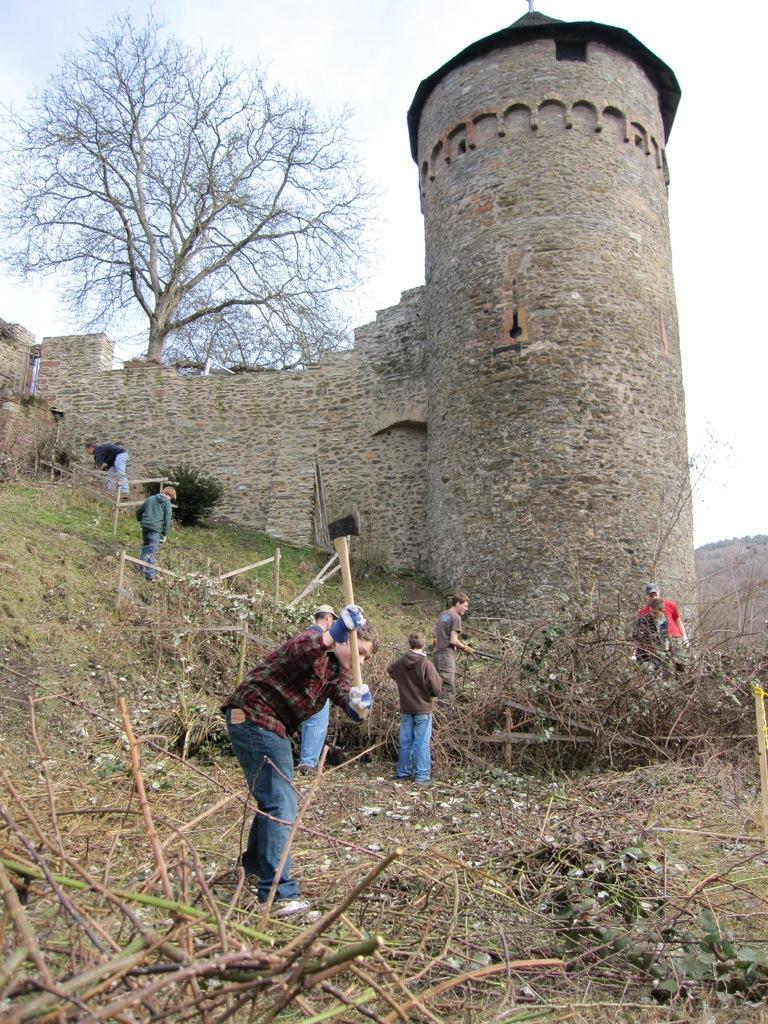What are the people in the image doing? People are standing in the image. Can you describe the person at the front? The person at the front is holding an axe. What type of structure can be seen in the image? There is a stone building in the image. What is located at the back of the image? A tree is present at the back of the image. What type of cattle can be seen grazing in the image? There is no cattle present in the image. What offer is being made by the person holding the axe? The person holding the axe is not making any offer in the image. 